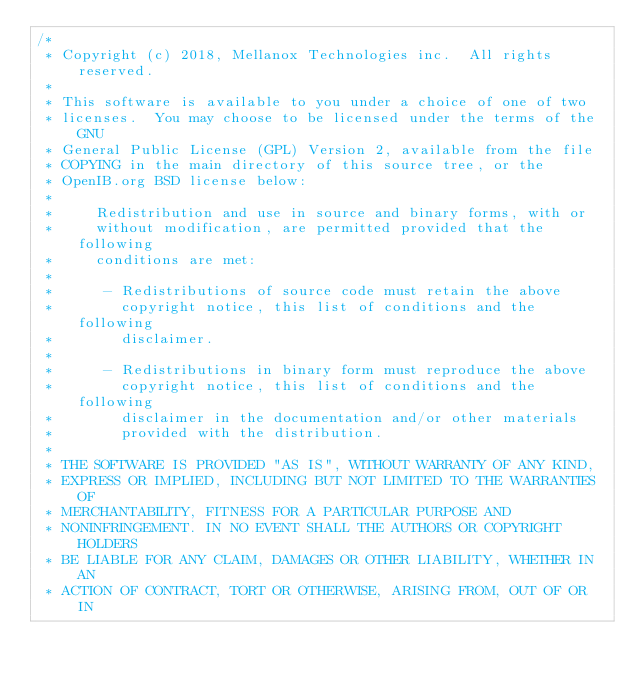<code> <loc_0><loc_0><loc_500><loc_500><_C_>/*
 * Copyright (c) 2018, Mellanox Technologies inc.  All rights reserved.
 *
 * This software is available to you under a choice of one of two
 * licenses.  You may choose to be licensed under the terms of the GNU
 * General Public License (GPL) Version 2, available from the file
 * COPYING in the main directory of this source tree, or the
 * OpenIB.org BSD license below:
 *
 *     Redistribution and use in source and binary forms, with or
 *     without modification, are permitted provided that the following
 *     conditions are met:
 *
 *      - Redistributions of source code must retain the above
 *        copyright notice, this list of conditions and the following
 *        disclaimer.
 *
 *      - Redistributions in binary form must reproduce the above
 *        copyright notice, this list of conditions and the following
 *        disclaimer in the documentation and/or other materials
 *        provided with the distribution.
 *
 * THE SOFTWARE IS PROVIDED "AS IS", WITHOUT WARRANTY OF ANY KIND,
 * EXPRESS OR IMPLIED, INCLUDING BUT NOT LIMITED TO THE WARRANTIES OF
 * MERCHANTABILITY, FITNESS FOR A PARTICULAR PURPOSE AND
 * NONINFRINGEMENT. IN NO EVENT SHALL THE AUTHORS OR COPYRIGHT HOLDERS
 * BE LIABLE FOR ANY CLAIM, DAMAGES OR OTHER LIABILITY, WHETHER IN AN
 * ACTION OF CONTRACT, TORT OR OTHERWISE, ARISING FROM, OUT OF OR IN</code> 